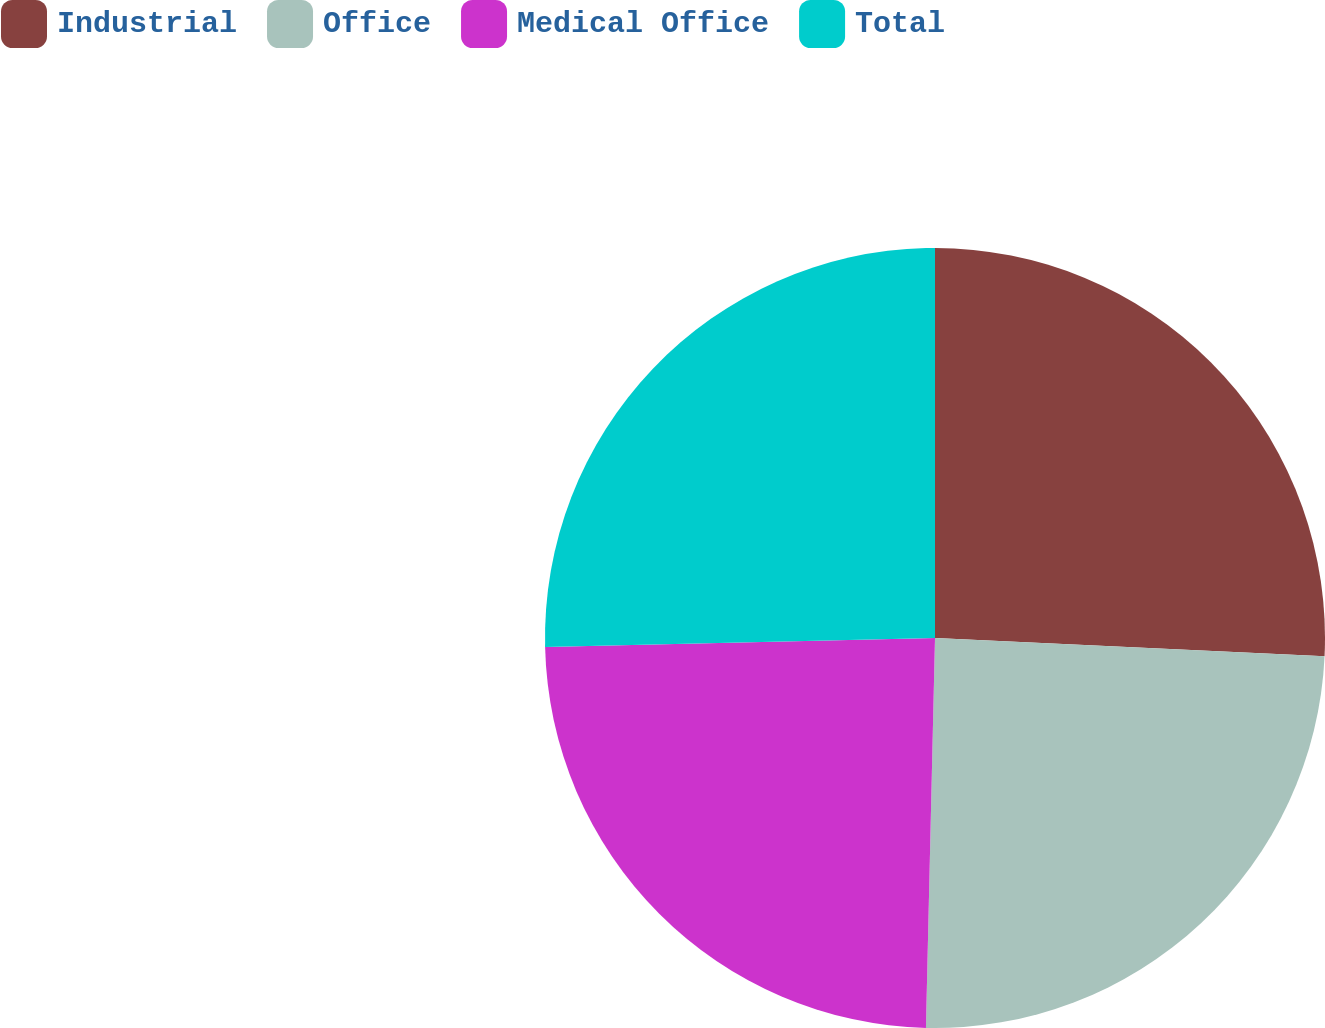Convert chart. <chart><loc_0><loc_0><loc_500><loc_500><pie_chart><fcel>Industrial<fcel>Office<fcel>Medical Office<fcel>Total<nl><fcel>25.74%<fcel>24.63%<fcel>24.26%<fcel>25.37%<nl></chart> 